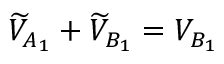<formula> <loc_0><loc_0><loc_500><loc_500>\widetilde { V } _ { A _ { 1 } } + \widetilde { V } _ { B _ { 1 } } = V _ { B _ { 1 } }</formula> 